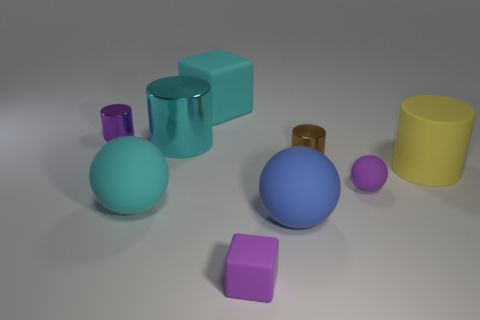Subtract all big balls. How many balls are left? 1 Subtract 2 spheres. How many spheres are left? 1 Subtract all cyan cylinders. How many cylinders are left? 3 Subtract all cylinders. How many objects are left? 5 Subtract all cyan cubes. Subtract all tiny purple cubes. How many objects are left? 7 Add 7 yellow matte cylinders. How many yellow matte cylinders are left? 8 Add 2 tiny purple balls. How many tiny purple balls exist? 3 Subtract 1 cyan blocks. How many objects are left? 8 Subtract all gray spheres. Subtract all red blocks. How many spheres are left? 3 Subtract all cyan blocks. How many green balls are left? 0 